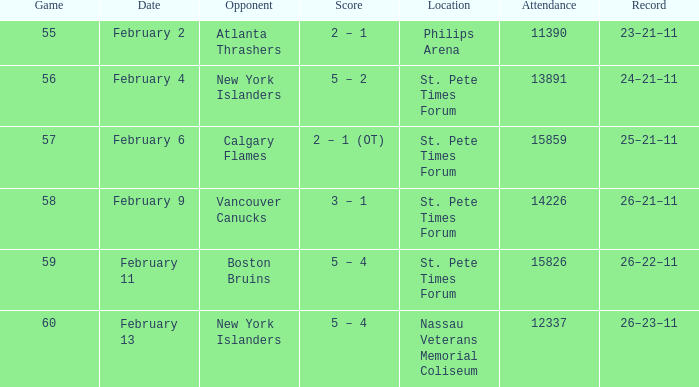What scores happened on February 9? 3 – 1. 